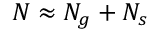<formula> <loc_0><loc_0><loc_500><loc_500>N \approx N _ { g } + N _ { s }</formula> 